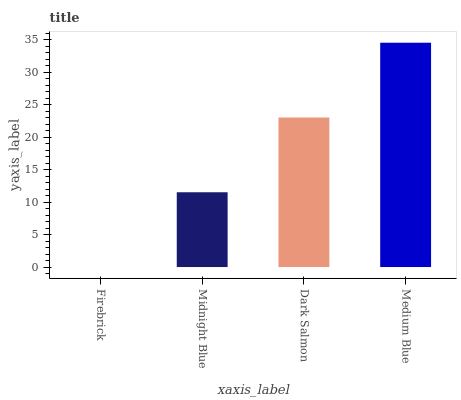Is Midnight Blue the minimum?
Answer yes or no. No. Is Midnight Blue the maximum?
Answer yes or no. No. Is Midnight Blue greater than Firebrick?
Answer yes or no. Yes. Is Firebrick less than Midnight Blue?
Answer yes or no. Yes. Is Firebrick greater than Midnight Blue?
Answer yes or no. No. Is Midnight Blue less than Firebrick?
Answer yes or no. No. Is Dark Salmon the high median?
Answer yes or no. Yes. Is Midnight Blue the low median?
Answer yes or no. Yes. Is Medium Blue the high median?
Answer yes or no. No. Is Medium Blue the low median?
Answer yes or no. No. 